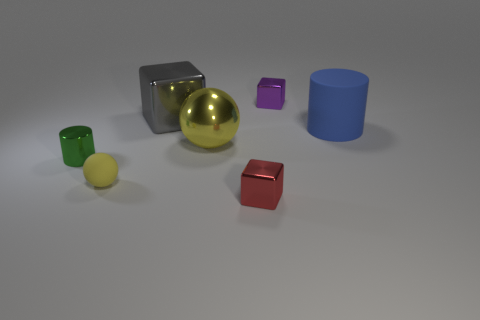Subtract all small metal cubes. How many cubes are left? 1 Add 2 small blue rubber blocks. How many objects exist? 9 Subtract all cubes. How many objects are left? 4 Subtract 0 blue balls. How many objects are left? 7 Subtract all large gray rubber things. Subtract all big gray shiny objects. How many objects are left? 6 Add 1 big yellow metal balls. How many big yellow metal balls are left? 2 Add 7 gray things. How many gray things exist? 8 